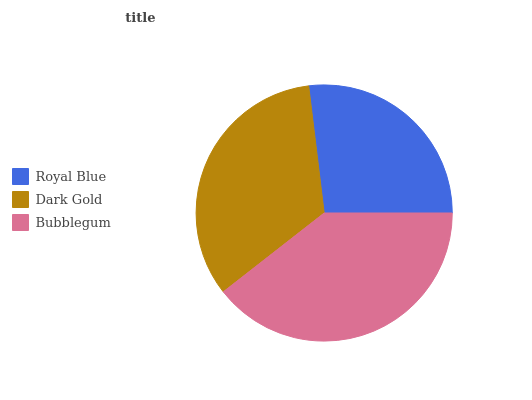Is Royal Blue the minimum?
Answer yes or no. Yes. Is Bubblegum the maximum?
Answer yes or no. Yes. Is Dark Gold the minimum?
Answer yes or no. No. Is Dark Gold the maximum?
Answer yes or no. No. Is Dark Gold greater than Royal Blue?
Answer yes or no. Yes. Is Royal Blue less than Dark Gold?
Answer yes or no. Yes. Is Royal Blue greater than Dark Gold?
Answer yes or no. No. Is Dark Gold less than Royal Blue?
Answer yes or no. No. Is Dark Gold the high median?
Answer yes or no. Yes. Is Dark Gold the low median?
Answer yes or no. Yes. Is Royal Blue the high median?
Answer yes or no. No. Is Bubblegum the low median?
Answer yes or no. No. 